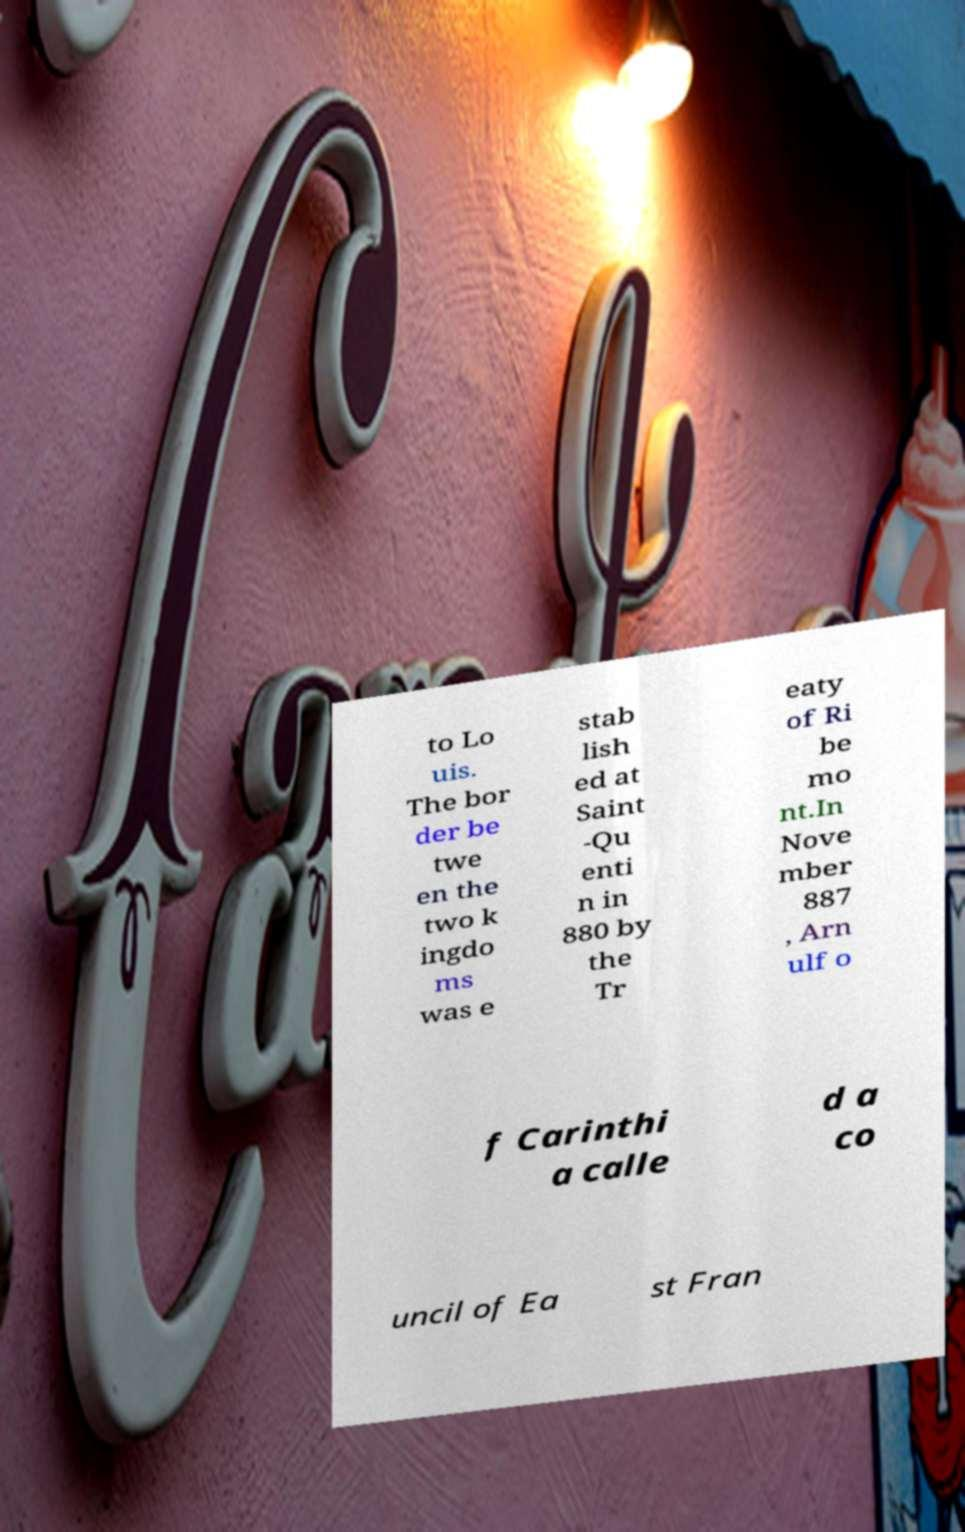What messages or text are displayed in this image? I need them in a readable, typed format. to Lo uis. The bor der be twe en the two k ingdo ms was e stab lish ed at Saint -Qu enti n in 880 by the Tr eaty of Ri be mo nt.In Nove mber 887 , Arn ulf o f Carinthi a calle d a co uncil of Ea st Fran 